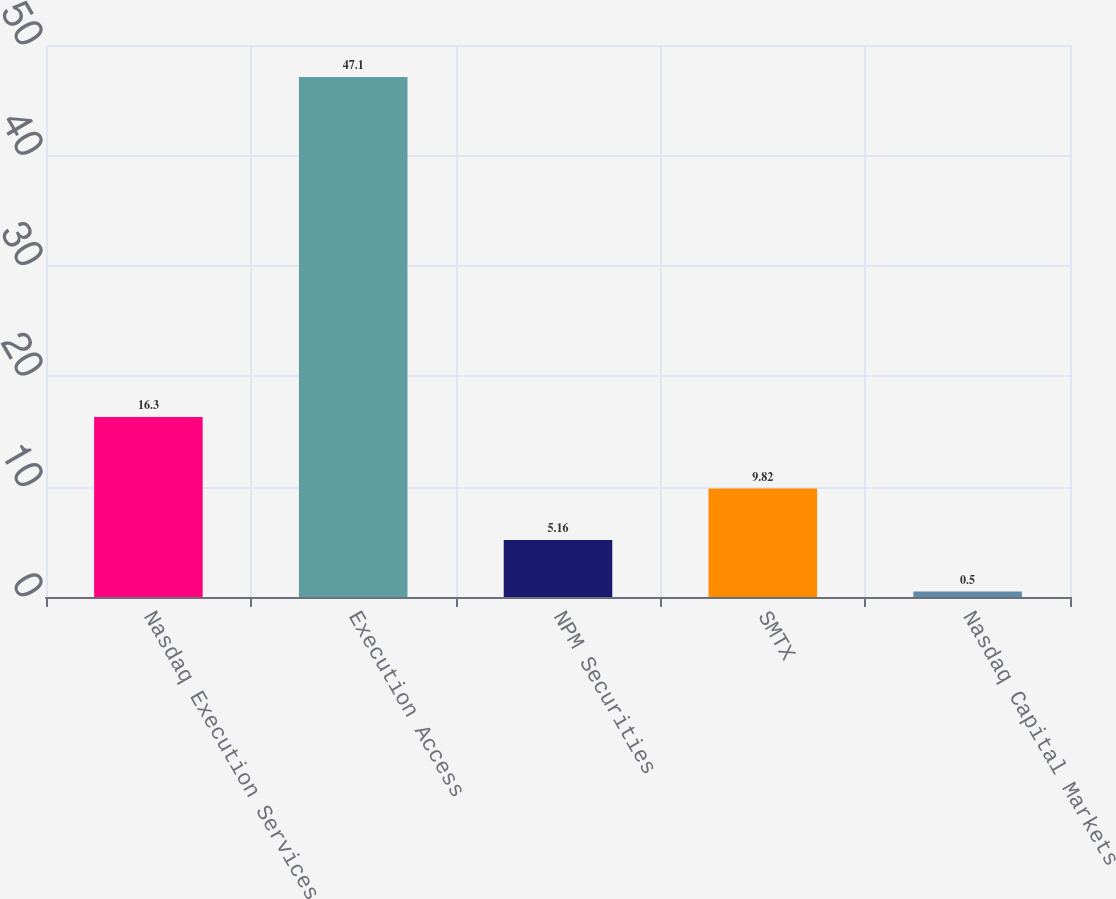Convert chart. <chart><loc_0><loc_0><loc_500><loc_500><bar_chart><fcel>Nasdaq Execution Services<fcel>Execution Access<fcel>NPM Securities<fcel>SMTX<fcel>Nasdaq Capital Markets<nl><fcel>16.3<fcel>47.1<fcel>5.16<fcel>9.82<fcel>0.5<nl></chart> 